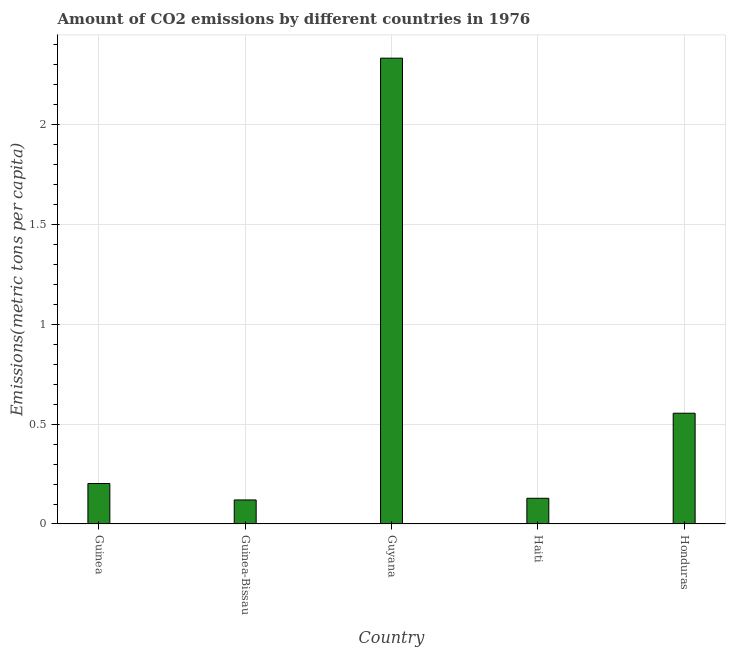Does the graph contain grids?
Your answer should be compact. Yes. What is the title of the graph?
Offer a very short reply. Amount of CO2 emissions by different countries in 1976. What is the label or title of the Y-axis?
Provide a succinct answer. Emissions(metric tons per capita). What is the amount of co2 emissions in Guinea?
Offer a very short reply. 0.2. Across all countries, what is the maximum amount of co2 emissions?
Your answer should be very brief. 2.33. Across all countries, what is the minimum amount of co2 emissions?
Provide a succinct answer. 0.12. In which country was the amount of co2 emissions maximum?
Give a very brief answer. Guyana. In which country was the amount of co2 emissions minimum?
Make the answer very short. Guinea-Bissau. What is the sum of the amount of co2 emissions?
Provide a short and direct response. 3.34. What is the difference between the amount of co2 emissions in Guinea and Honduras?
Give a very brief answer. -0.35. What is the average amount of co2 emissions per country?
Offer a terse response. 0.67. What is the median amount of co2 emissions?
Offer a very short reply. 0.2. What is the ratio of the amount of co2 emissions in Guinea-Bissau to that in Haiti?
Give a very brief answer. 0.94. Is the amount of co2 emissions in Guinea less than that in Honduras?
Your response must be concise. Yes. What is the difference between the highest and the second highest amount of co2 emissions?
Make the answer very short. 1.78. Is the sum of the amount of co2 emissions in Guyana and Haiti greater than the maximum amount of co2 emissions across all countries?
Offer a very short reply. Yes. What is the difference between the highest and the lowest amount of co2 emissions?
Provide a short and direct response. 2.21. How many bars are there?
Keep it short and to the point. 5. How many countries are there in the graph?
Make the answer very short. 5. What is the difference between two consecutive major ticks on the Y-axis?
Ensure brevity in your answer.  0.5. Are the values on the major ticks of Y-axis written in scientific E-notation?
Offer a terse response. No. What is the Emissions(metric tons per capita) of Guinea?
Your answer should be very brief. 0.2. What is the Emissions(metric tons per capita) in Guinea-Bissau?
Provide a short and direct response. 0.12. What is the Emissions(metric tons per capita) in Guyana?
Provide a succinct answer. 2.33. What is the Emissions(metric tons per capita) in Haiti?
Provide a succinct answer. 0.13. What is the Emissions(metric tons per capita) of Honduras?
Provide a short and direct response. 0.55. What is the difference between the Emissions(metric tons per capita) in Guinea and Guinea-Bissau?
Keep it short and to the point. 0.08. What is the difference between the Emissions(metric tons per capita) in Guinea and Guyana?
Your answer should be very brief. -2.13. What is the difference between the Emissions(metric tons per capita) in Guinea and Haiti?
Give a very brief answer. 0.07. What is the difference between the Emissions(metric tons per capita) in Guinea and Honduras?
Your answer should be very brief. -0.35. What is the difference between the Emissions(metric tons per capita) in Guinea-Bissau and Guyana?
Make the answer very short. -2.21. What is the difference between the Emissions(metric tons per capita) in Guinea-Bissau and Haiti?
Your answer should be compact. -0.01. What is the difference between the Emissions(metric tons per capita) in Guinea-Bissau and Honduras?
Your answer should be compact. -0.43. What is the difference between the Emissions(metric tons per capita) in Guyana and Haiti?
Your answer should be compact. 2.21. What is the difference between the Emissions(metric tons per capita) in Guyana and Honduras?
Offer a terse response. 1.78. What is the difference between the Emissions(metric tons per capita) in Haiti and Honduras?
Provide a succinct answer. -0.43. What is the ratio of the Emissions(metric tons per capita) in Guinea to that in Guinea-Bissau?
Provide a succinct answer. 1.68. What is the ratio of the Emissions(metric tons per capita) in Guinea to that in Guyana?
Ensure brevity in your answer.  0.09. What is the ratio of the Emissions(metric tons per capita) in Guinea to that in Haiti?
Ensure brevity in your answer.  1.57. What is the ratio of the Emissions(metric tons per capita) in Guinea to that in Honduras?
Your response must be concise. 0.36. What is the ratio of the Emissions(metric tons per capita) in Guinea-Bissau to that in Guyana?
Offer a very short reply. 0.05. What is the ratio of the Emissions(metric tons per capita) in Guinea-Bissau to that in Haiti?
Make the answer very short. 0.94. What is the ratio of the Emissions(metric tons per capita) in Guinea-Bissau to that in Honduras?
Provide a short and direct response. 0.22. What is the ratio of the Emissions(metric tons per capita) in Guyana to that in Haiti?
Give a very brief answer. 18.12. What is the ratio of the Emissions(metric tons per capita) in Guyana to that in Honduras?
Offer a terse response. 4.21. What is the ratio of the Emissions(metric tons per capita) in Haiti to that in Honduras?
Offer a terse response. 0.23. 